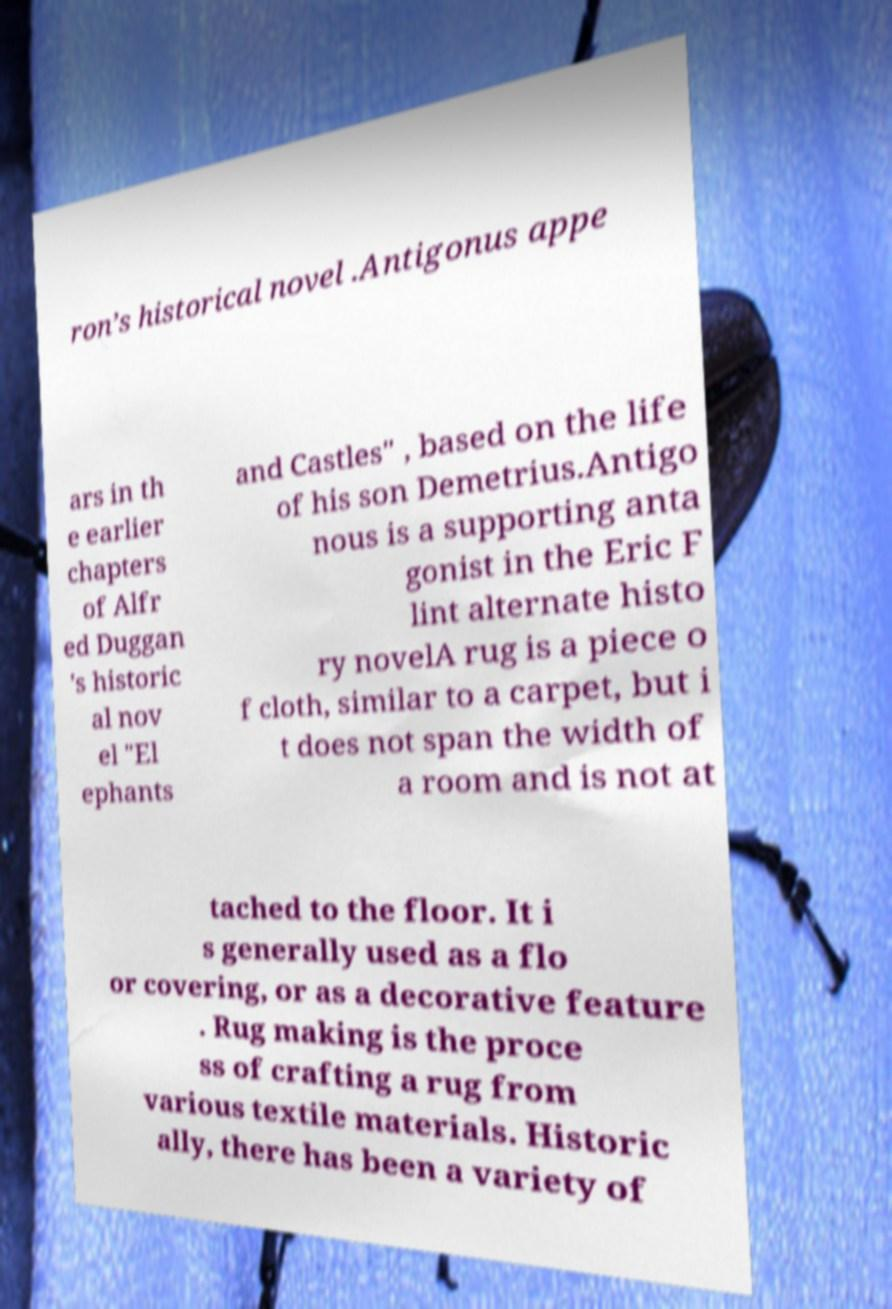I need the written content from this picture converted into text. Can you do that? ron’s historical novel .Antigonus appe ars in th e earlier chapters of Alfr ed Duggan 's historic al nov el "El ephants and Castles" , based on the life of his son Demetrius.Antigo nous is a supporting anta gonist in the Eric F lint alternate histo ry novelA rug is a piece o f cloth, similar to a carpet, but i t does not span the width of a room and is not at tached to the floor. It i s generally used as a flo or covering, or as a decorative feature . Rug making is the proce ss of crafting a rug from various textile materials. Historic ally, there has been a variety of 